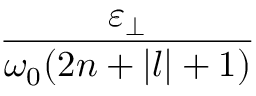<formula> <loc_0><loc_0><loc_500><loc_500>\frac { \varepsilon _ { \perp } } { \omega _ { 0 } ( 2 n + | l | + 1 ) }</formula> 